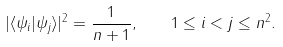<formula> <loc_0><loc_0><loc_500><loc_500>| \langle \psi _ { i } | \psi _ { j } \rangle | ^ { 2 } = \frac { 1 } { n + 1 } , \quad 1 \leq i < j \leq n ^ { 2 } .</formula> 